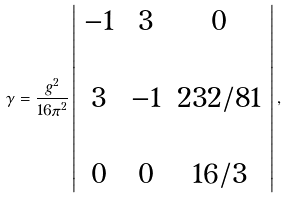Convert formula to latex. <formula><loc_0><loc_0><loc_500><loc_500>\gamma = \frac { g ^ { 2 } } { 1 6 \pi ^ { 2 } } \left | \begin{array} { c c c } - 1 & 3 & 0 \\ \\ 3 & - 1 & 2 3 2 / 8 1 \\ \\ 0 & 0 & 1 6 / 3 \end{array} \right | ,</formula> 